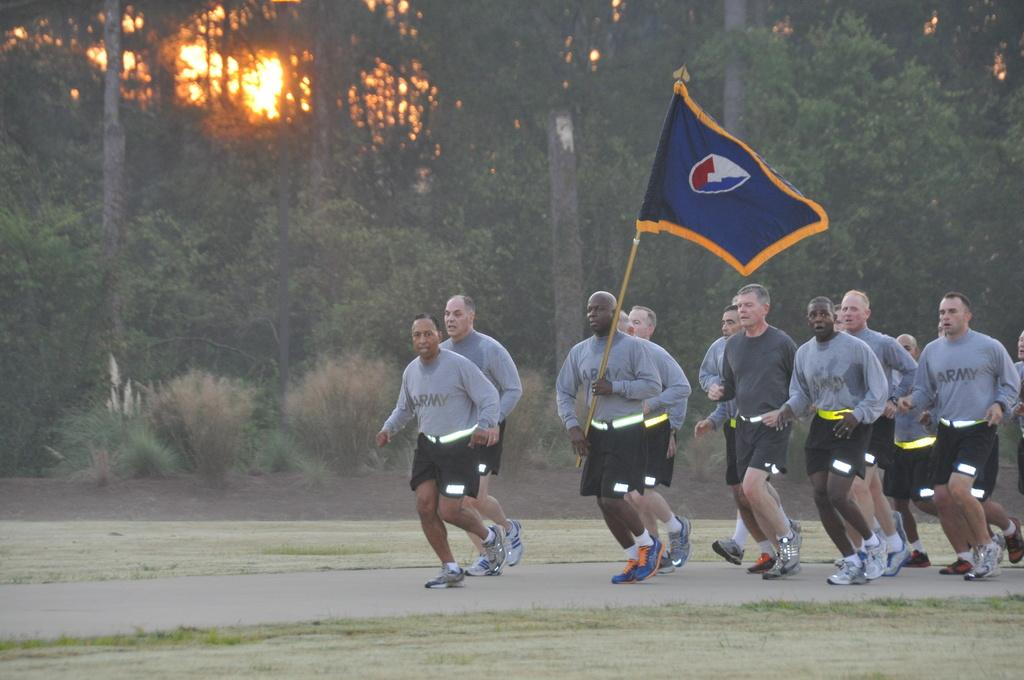What are the people in the image doing? People are running in the image. What color are the t-shirts worn by the people? The people are wearing grey t-shirts. What color are the shorts worn by the people? The people are wearing black shorts. What object is being held by one of the people? A person is holding a blue flag. What can be seen in the background of the image? There are trees visible in the background. What is visible in the sky in the image? The sun is visible in the image. What type of poison is being used by the people in the image? There is no mention of poison in the image; the people are running and wearing specific clothing. What kind of mark can be seen on the shoes of the people in the image? There is no mention of shoes in the image; the people are wearing grey t-shirts and black shorts. 